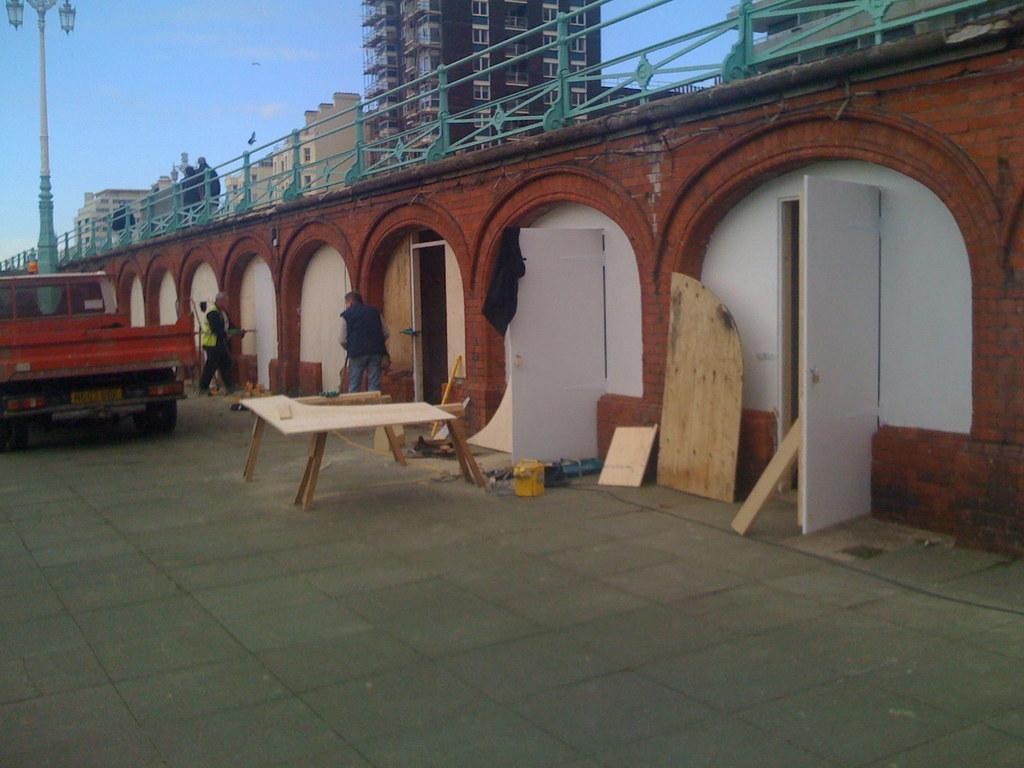Please provide a concise description of this image. This is the picture of a building. In the foreground there is a table and there are objects and there are two persons standing and there is a vehicle and pole on the road. At the back there is a bridge and there are buildings. At the top there is sky. At the bottom there is a road. 